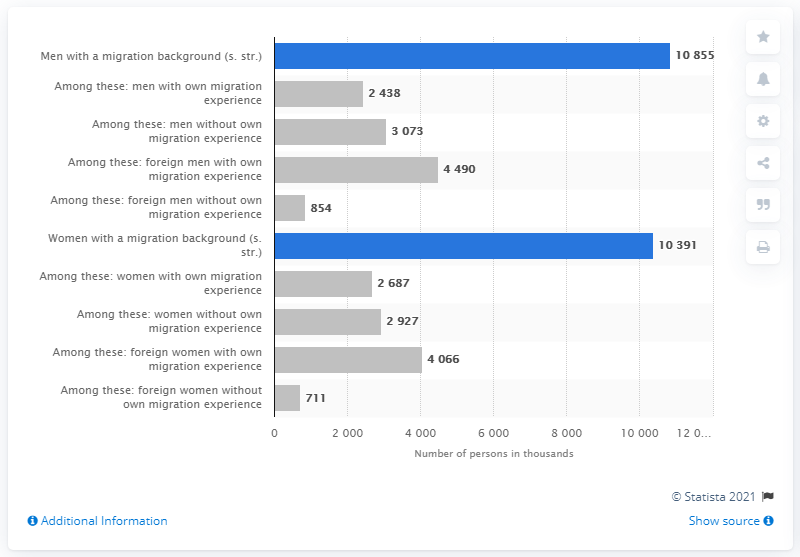List a handful of essential elements in this visual. The average height of men is higher than that of women by 464 millimeters. Men with a migration background have the highest prevalence of background. 